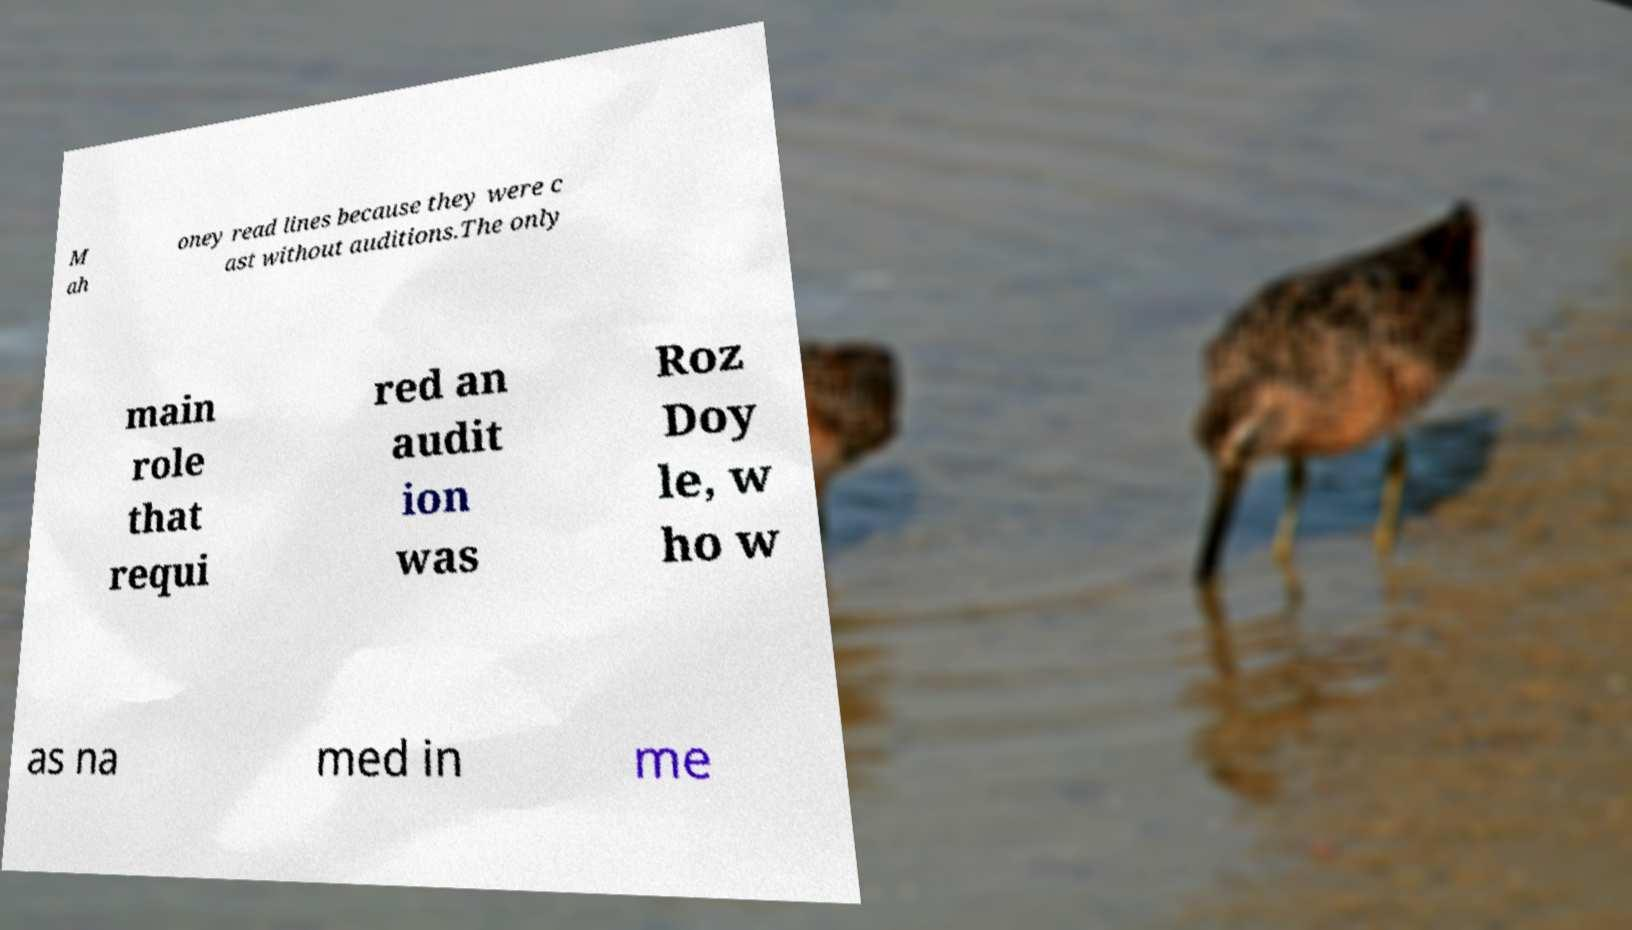I need the written content from this picture converted into text. Can you do that? M ah oney read lines because they were c ast without auditions.The only main role that requi red an audit ion was Roz Doy le, w ho w as na med in me 